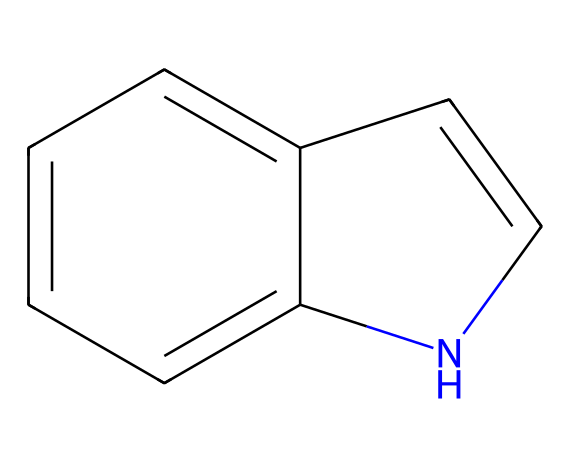What is the molecular formula of indole? To find the molecular formula, we count the atoms of each element present in the structure. The structure of indole shows 8 carbon atoms, 7 hydrogen atoms, and 1 nitrogen atom. Therefore, the molecular formula is C8H7N.
Answer: C8H7N How many rings are present in indole? Indole contains two fused rings in its structure; one is a six-membered benzene ring and the other is a five-membered nitrogen-containing ring.
Answer: 2 What type of compound is indole? Indole is classified as an aromatic compound due to its stable structure and the presence of a conjugated pi system across the cyclic structure.
Answer: aromatic What functional group is present in indole? Indole has a nitrogen atom within its ring structure, making it a part of the heterocyclic amine category. Heterocycles contain atoms other than carbon in their ring, in this case, nitrogen.
Answer: nitrogen What type of bonding is predominantly seen in indole? The chemical structure indicates the presence of delocalized pi electrons across the aromatic system. This indicates that there are π-bonds due to resonance between the carbon atoms and the nitrogen atom in the rings.
Answer: π-bonds Why is indole important in fragrance? Indole is known for its jasmine-like scent, contributing to the floral fragrance profile of many perfumes. This characteristic is due to its unique chemical structure which can interact with olfactory receptors.
Answer: jasmine scent 